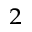Convert formula to latex. <formula><loc_0><loc_0><loc_500><loc_500>_ { 2 }</formula> 